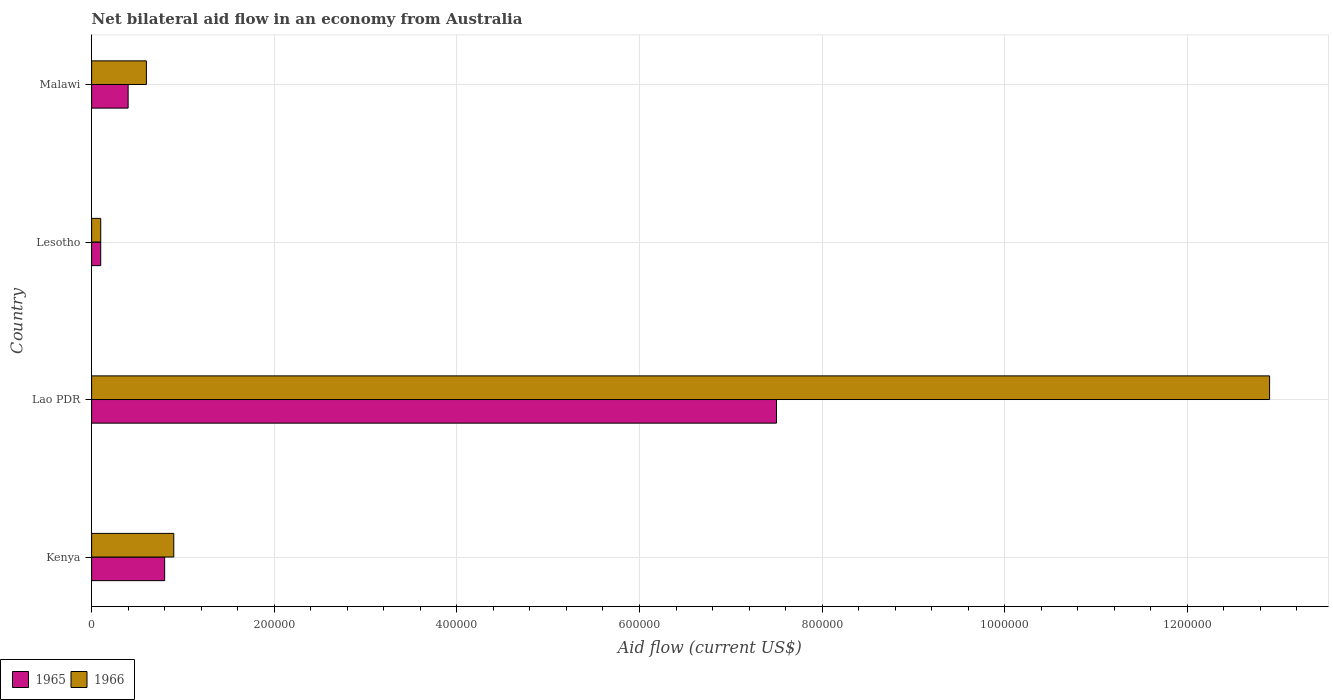How many groups of bars are there?
Make the answer very short. 4. Are the number of bars per tick equal to the number of legend labels?
Offer a very short reply. Yes. Are the number of bars on each tick of the Y-axis equal?
Keep it short and to the point. Yes. How many bars are there on the 3rd tick from the top?
Keep it short and to the point. 2. What is the label of the 4th group of bars from the top?
Provide a short and direct response. Kenya. What is the net bilateral aid flow in 1966 in Lao PDR?
Your answer should be very brief. 1.29e+06. Across all countries, what is the maximum net bilateral aid flow in 1965?
Offer a very short reply. 7.50e+05. Across all countries, what is the minimum net bilateral aid flow in 1966?
Offer a terse response. 10000. In which country was the net bilateral aid flow in 1965 maximum?
Your answer should be very brief. Lao PDR. In which country was the net bilateral aid flow in 1966 minimum?
Make the answer very short. Lesotho. What is the total net bilateral aid flow in 1966 in the graph?
Ensure brevity in your answer.  1.45e+06. What is the difference between the net bilateral aid flow in 1965 in Kenya and that in Malawi?
Provide a short and direct response. 4.00e+04. What is the difference between the net bilateral aid flow in 1966 in Kenya and the net bilateral aid flow in 1965 in Lao PDR?
Ensure brevity in your answer.  -6.60e+05. What is the average net bilateral aid flow in 1965 per country?
Give a very brief answer. 2.20e+05. What is the difference between the net bilateral aid flow in 1965 and net bilateral aid flow in 1966 in Lao PDR?
Offer a terse response. -5.40e+05. In how many countries, is the net bilateral aid flow in 1966 greater than 1120000 US$?
Your response must be concise. 1. Is the difference between the net bilateral aid flow in 1965 in Lao PDR and Lesotho greater than the difference between the net bilateral aid flow in 1966 in Lao PDR and Lesotho?
Provide a succinct answer. No. What is the difference between the highest and the second highest net bilateral aid flow in 1966?
Ensure brevity in your answer.  1.20e+06. What is the difference between the highest and the lowest net bilateral aid flow in 1966?
Offer a very short reply. 1.28e+06. In how many countries, is the net bilateral aid flow in 1965 greater than the average net bilateral aid flow in 1965 taken over all countries?
Provide a succinct answer. 1. What does the 2nd bar from the top in Malawi represents?
Offer a very short reply. 1965. What does the 1st bar from the bottom in Kenya represents?
Offer a terse response. 1965. How many bars are there?
Your answer should be compact. 8. Are all the bars in the graph horizontal?
Ensure brevity in your answer.  Yes. How many countries are there in the graph?
Your response must be concise. 4. What is the title of the graph?
Make the answer very short. Net bilateral aid flow in an economy from Australia. Does "1969" appear as one of the legend labels in the graph?
Your answer should be compact. No. What is the label or title of the Y-axis?
Your answer should be very brief. Country. What is the Aid flow (current US$) in 1965 in Kenya?
Provide a succinct answer. 8.00e+04. What is the Aid flow (current US$) in 1965 in Lao PDR?
Provide a short and direct response. 7.50e+05. What is the Aid flow (current US$) in 1966 in Lao PDR?
Ensure brevity in your answer.  1.29e+06. What is the Aid flow (current US$) in 1965 in Lesotho?
Your answer should be compact. 10000. Across all countries, what is the maximum Aid flow (current US$) of 1965?
Ensure brevity in your answer.  7.50e+05. Across all countries, what is the maximum Aid flow (current US$) in 1966?
Offer a very short reply. 1.29e+06. What is the total Aid flow (current US$) of 1965 in the graph?
Your response must be concise. 8.80e+05. What is the total Aid flow (current US$) in 1966 in the graph?
Your response must be concise. 1.45e+06. What is the difference between the Aid flow (current US$) in 1965 in Kenya and that in Lao PDR?
Offer a terse response. -6.70e+05. What is the difference between the Aid flow (current US$) in 1966 in Kenya and that in Lao PDR?
Provide a succinct answer. -1.20e+06. What is the difference between the Aid flow (current US$) of 1965 in Kenya and that in Lesotho?
Provide a short and direct response. 7.00e+04. What is the difference between the Aid flow (current US$) in 1965 in Lao PDR and that in Lesotho?
Keep it short and to the point. 7.40e+05. What is the difference between the Aid flow (current US$) in 1966 in Lao PDR and that in Lesotho?
Offer a very short reply. 1.28e+06. What is the difference between the Aid flow (current US$) in 1965 in Lao PDR and that in Malawi?
Give a very brief answer. 7.10e+05. What is the difference between the Aid flow (current US$) of 1966 in Lao PDR and that in Malawi?
Your answer should be compact. 1.23e+06. What is the difference between the Aid flow (current US$) in 1965 in Lesotho and that in Malawi?
Offer a terse response. -3.00e+04. What is the difference between the Aid flow (current US$) of 1966 in Lesotho and that in Malawi?
Ensure brevity in your answer.  -5.00e+04. What is the difference between the Aid flow (current US$) of 1965 in Kenya and the Aid flow (current US$) of 1966 in Lao PDR?
Keep it short and to the point. -1.21e+06. What is the difference between the Aid flow (current US$) in 1965 in Lao PDR and the Aid flow (current US$) in 1966 in Lesotho?
Give a very brief answer. 7.40e+05. What is the difference between the Aid flow (current US$) in 1965 in Lao PDR and the Aid flow (current US$) in 1966 in Malawi?
Your answer should be compact. 6.90e+05. What is the average Aid flow (current US$) in 1965 per country?
Your answer should be compact. 2.20e+05. What is the average Aid flow (current US$) in 1966 per country?
Your answer should be very brief. 3.62e+05. What is the difference between the Aid flow (current US$) of 1965 and Aid flow (current US$) of 1966 in Lao PDR?
Offer a terse response. -5.40e+05. What is the ratio of the Aid flow (current US$) in 1965 in Kenya to that in Lao PDR?
Keep it short and to the point. 0.11. What is the ratio of the Aid flow (current US$) of 1966 in Kenya to that in Lao PDR?
Your answer should be compact. 0.07. What is the ratio of the Aid flow (current US$) in 1966 in Kenya to that in Lesotho?
Provide a short and direct response. 9. What is the ratio of the Aid flow (current US$) in 1966 in Lao PDR to that in Lesotho?
Make the answer very short. 129. What is the ratio of the Aid flow (current US$) in 1965 in Lao PDR to that in Malawi?
Offer a terse response. 18.75. What is the ratio of the Aid flow (current US$) of 1966 in Lao PDR to that in Malawi?
Your answer should be compact. 21.5. What is the ratio of the Aid flow (current US$) of 1965 in Lesotho to that in Malawi?
Offer a very short reply. 0.25. What is the difference between the highest and the second highest Aid flow (current US$) of 1965?
Make the answer very short. 6.70e+05. What is the difference between the highest and the second highest Aid flow (current US$) in 1966?
Your answer should be very brief. 1.20e+06. What is the difference between the highest and the lowest Aid flow (current US$) in 1965?
Keep it short and to the point. 7.40e+05. What is the difference between the highest and the lowest Aid flow (current US$) in 1966?
Your answer should be compact. 1.28e+06. 